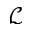Convert formula to latex. <formula><loc_0><loc_0><loc_500><loc_500>\mathcal { L }</formula> 